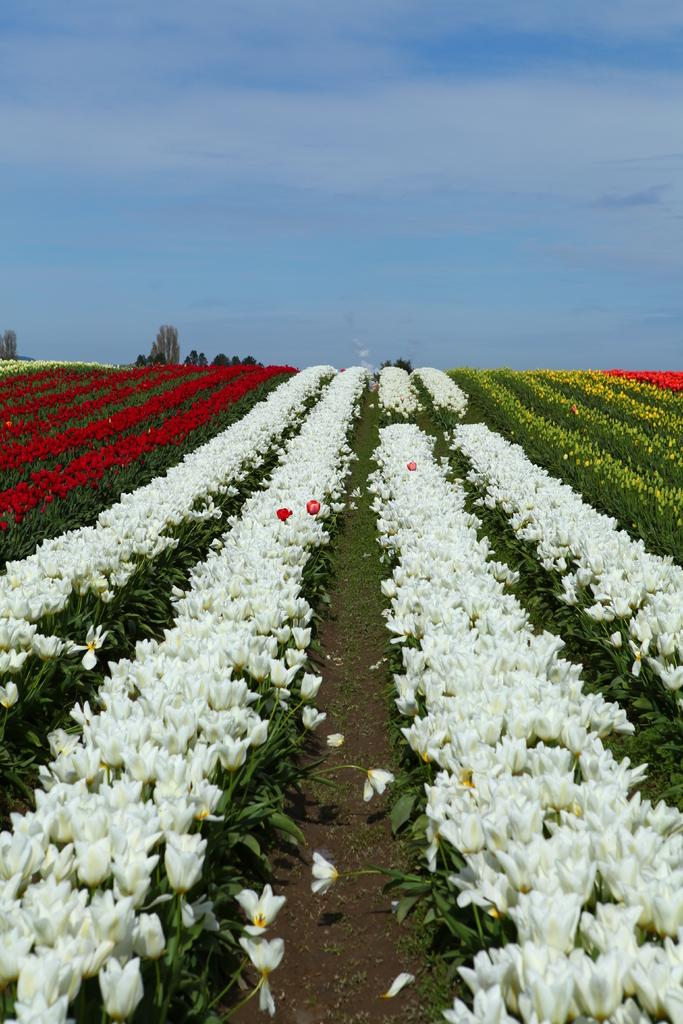What types of flowers can be seen in the image? There are different color flowers in the image. Where are the flowers located? The flowers are on plants. What can be seen in the background of the image? There is sky visible in the background of the image. What type of boot is visible in the image? There is no boot present in the image. What degree of education is required to identify the flowers in the image? Identifying the flowers in the image does not require any specific degree of education. 